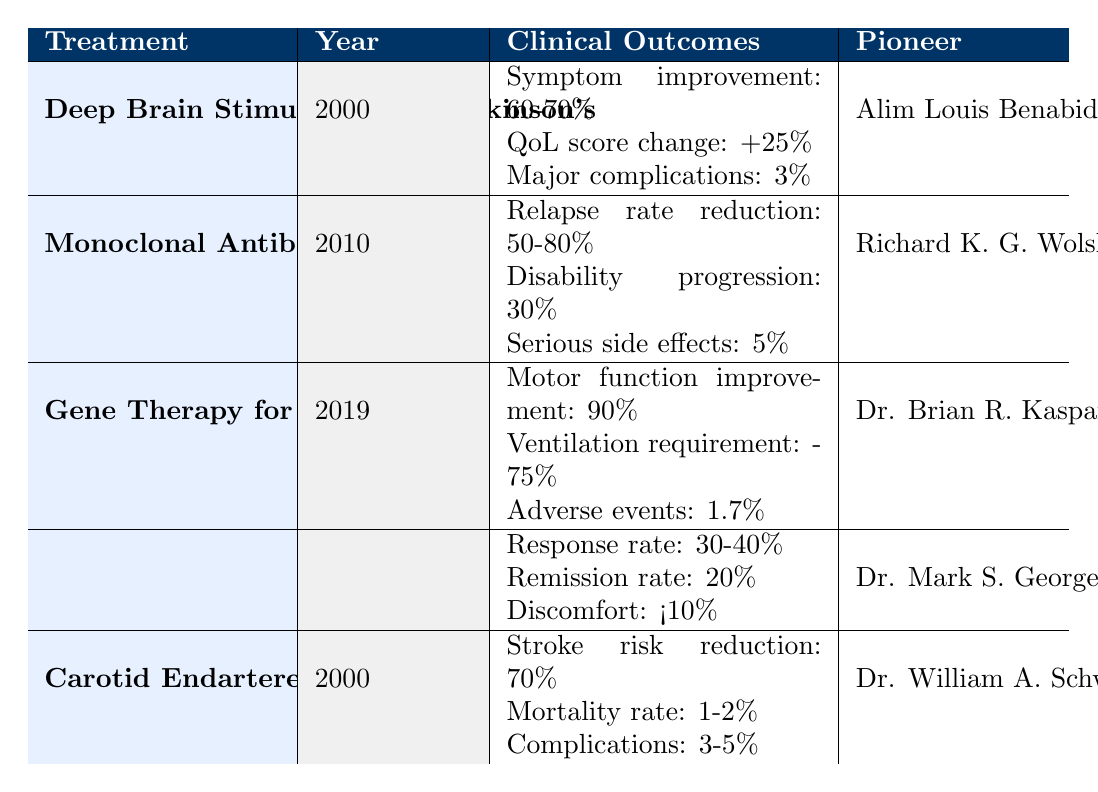What is the improvement in symptoms for Deep Brain Stimulation for Parkinson's Disease? The table shows that the improvement in symptoms for Deep Brain Stimulation is reported as 60-70%. Therefore, the answer can be found directly by referring to this specific statistic in the table.
Answer: 60-70% Who is the pioneer behind Monoclonal Antibodies for Multiple Sclerosis? The table clearly lists Richard K. G. Wolski as the pioneer for Monoclonal Antibodies for Multiple Sclerosis under the respective treatment. Thus, the answer can be directly extracted from the relevant row in the table.
Answer: Richard K. G. Wolski What is the percentage of serious side effects associated with Monoclonal Antibodies for Multiple Sclerosis? According to the table, the serious side effects for Monoclonal Antibodies are reported as 5%. This value can be directly referenced from the data.
Answer: 5% What is the average reduction in the requirement for invasive ventilation among patients treated with Gene Therapy for Spinal Muscular Atrophy? The table shows a 75% decrease in the requirement for invasive ventilation. Since there's only one value, the average is the same as this value. Therefore, the average reduction is also 75%.
Answer: 75% Is the response rate for Transcranial Magnetic Stimulation for Depression greater than 25%? The table indicates that the response rate for Transcranial Magnetic Stimulation is between 30-40% which is greater than 25%. Therefore, the answer is yes based on the data presented.
Answer: Yes Which treatment has the highest percentage of improvement in clinical outcomes? By comparing all the improvement percentages across the treatments listed in the table, Gene Therapy for Spinal Muscular Atrophy shows that motor function improvement reaches 90%, which is the highest value among them. Each treatment's percentage was analyzed, identifying Gene Therapy as the one with the highest outcome.
Answer: Gene Therapy for Spinal Muscular Atrophy What are the major complications reported for Deep Brain Stimulation? In the table, it is stated that major complications for Deep Brain Stimulation are reported to be at 3%. This can be found in the clinical outcomes section of the relevant treatment's row.
Answer: 3% How does the stroke risk reduction of Carotid Endarterectomy compare to the symptom improvement of Deep Brain Stimulation? The table shows a 70% reduction in stroke risk for Carotid Endarterectomy versus a 60-70% improvement in symptoms for Deep Brain Stimulation. This means the symptom improvement could be equal to or slightly lower than the stroke risk reduction, but based on the data provided, it is unclear which is definitively better without further specification. Thus, the comparison indicates they are similar in their high efficacy rates.
Answer: Similar in efficacy rates What is the association of adverse events with Gene Therapy for Spinal Muscular Atrophy? According to the table, the adverse events are listed as 1.7% for Gene Therapy for Spinal Muscular Atrophy. This statistic provides a direct quantitative measure of the potential negative outcomes associated with this treatment.
Answer: 1.7% 